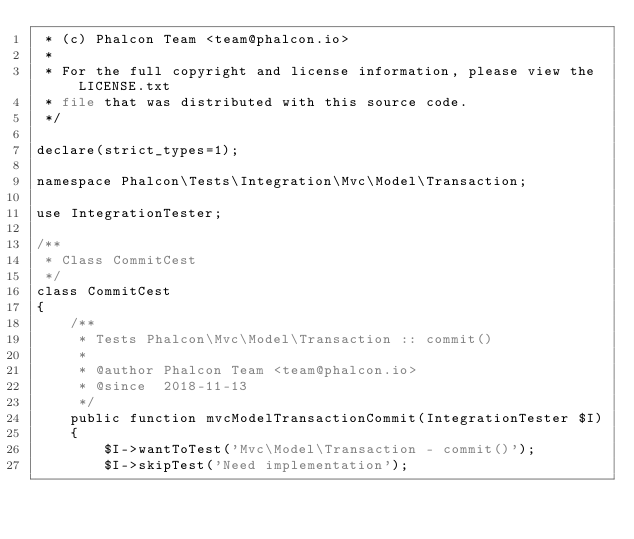Convert code to text. <code><loc_0><loc_0><loc_500><loc_500><_PHP_> * (c) Phalcon Team <team@phalcon.io>
 *
 * For the full copyright and license information, please view the LICENSE.txt
 * file that was distributed with this source code.
 */

declare(strict_types=1);

namespace Phalcon\Tests\Integration\Mvc\Model\Transaction;

use IntegrationTester;

/**
 * Class CommitCest
 */
class CommitCest
{
    /**
     * Tests Phalcon\Mvc\Model\Transaction :: commit()
     *
     * @author Phalcon Team <team@phalcon.io>
     * @since  2018-11-13
     */
    public function mvcModelTransactionCommit(IntegrationTester $I)
    {
        $I->wantToTest('Mvc\Model\Transaction - commit()');
        $I->skipTest('Need implementation');</code> 